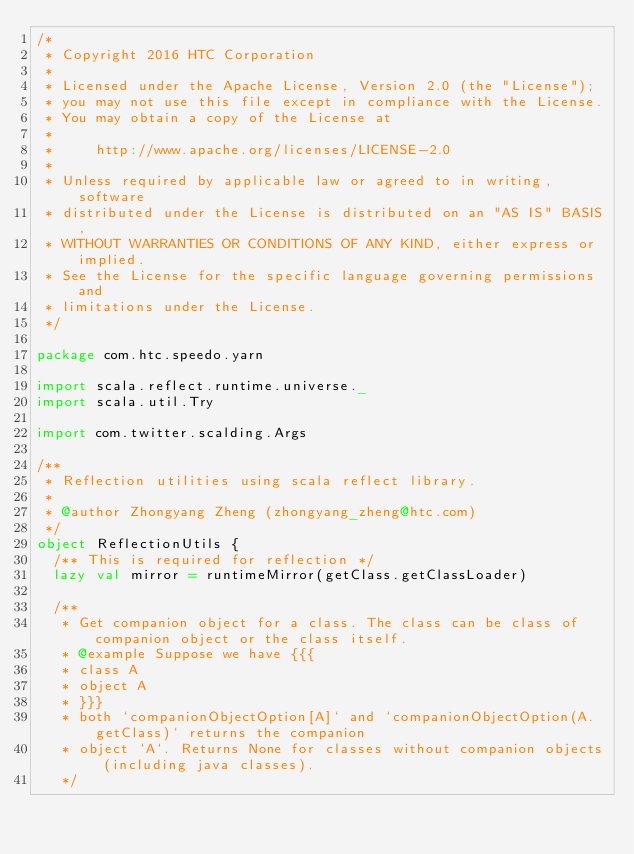Convert code to text. <code><loc_0><loc_0><loc_500><loc_500><_Scala_>/*
 * Copyright 2016 HTC Corporation
 *
 * Licensed under the Apache License, Version 2.0 (the "License");
 * you may not use this file except in compliance with the License.
 * You may obtain a copy of the License at
 *
 *     http://www.apache.org/licenses/LICENSE-2.0
 *
 * Unless required by applicable law or agreed to in writing, software
 * distributed under the License is distributed on an "AS IS" BASIS,
 * WITHOUT WARRANTIES OR CONDITIONS OF ANY KIND, either express or implied.
 * See the License for the specific language governing permissions and
 * limitations under the License.
 */

package com.htc.speedo.yarn

import scala.reflect.runtime.universe._
import scala.util.Try

import com.twitter.scalding.Args

/**
 * Reflection utilities using scala reflect library.
 *
 * @author Zhongyang Zheng (zhongyang_zheng@htc.com)
 */
object ReflectionUtils {
  /** This is required for reflection */
  lazy val mirror = runtimeMirror(getClass.getClassLoader)

  /**
   * Get companion object for a class. The class can be class of companion object or the class itself.
   * @example Suppose we have {{{
   * class A
   * object A
   * }}}
   * both `companionObjectOption[A]` and `companionObjectOption(A.getClass)` returns the companion
   * object `A`. Returns None for classes without companion objects (including java classes).
   */</code> 